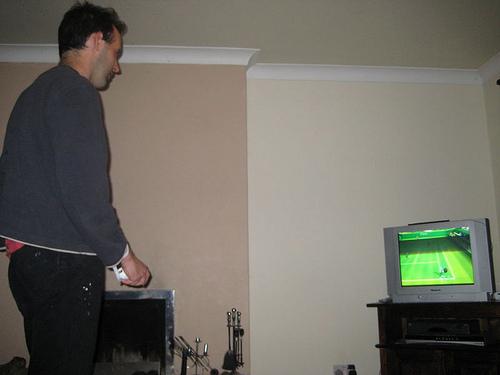What is the man in the scene doing with the TV?
Write a very short answer. Playing game. What game is the man playing?
Be succinct. Tennis. What devices are the boys playing?
Short answer required. Wii. What colors are the walls?
Concise answer only. Beige. Why do they stand to play?
Be succinct. Easier. 